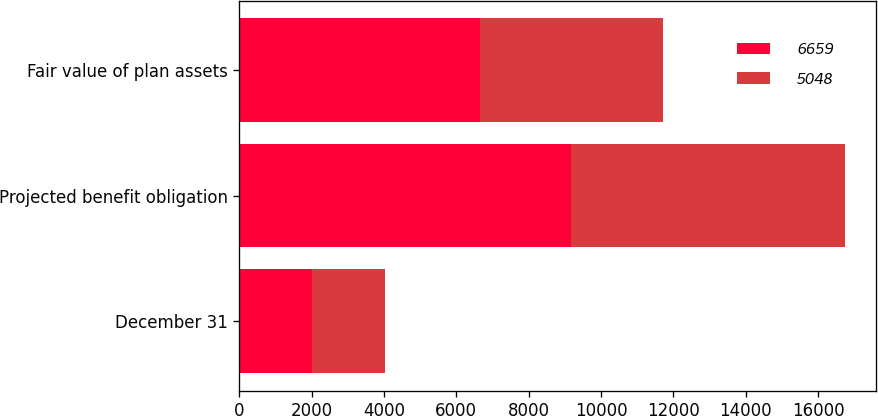Convert chart. <chart><loc_0><loc_0><loc_500><loc_500><stacked_bar_chart><ecel><fcel>December 31<fcel>Projected benefit obligation<fcel>Fair value of plan assets<nl><fcel>6659<fcel>2012<fcel>9161<fcel>6659<nl><fcel>5048<fcel>2011<fcel>7591<fcel>5048<nl></chart> 